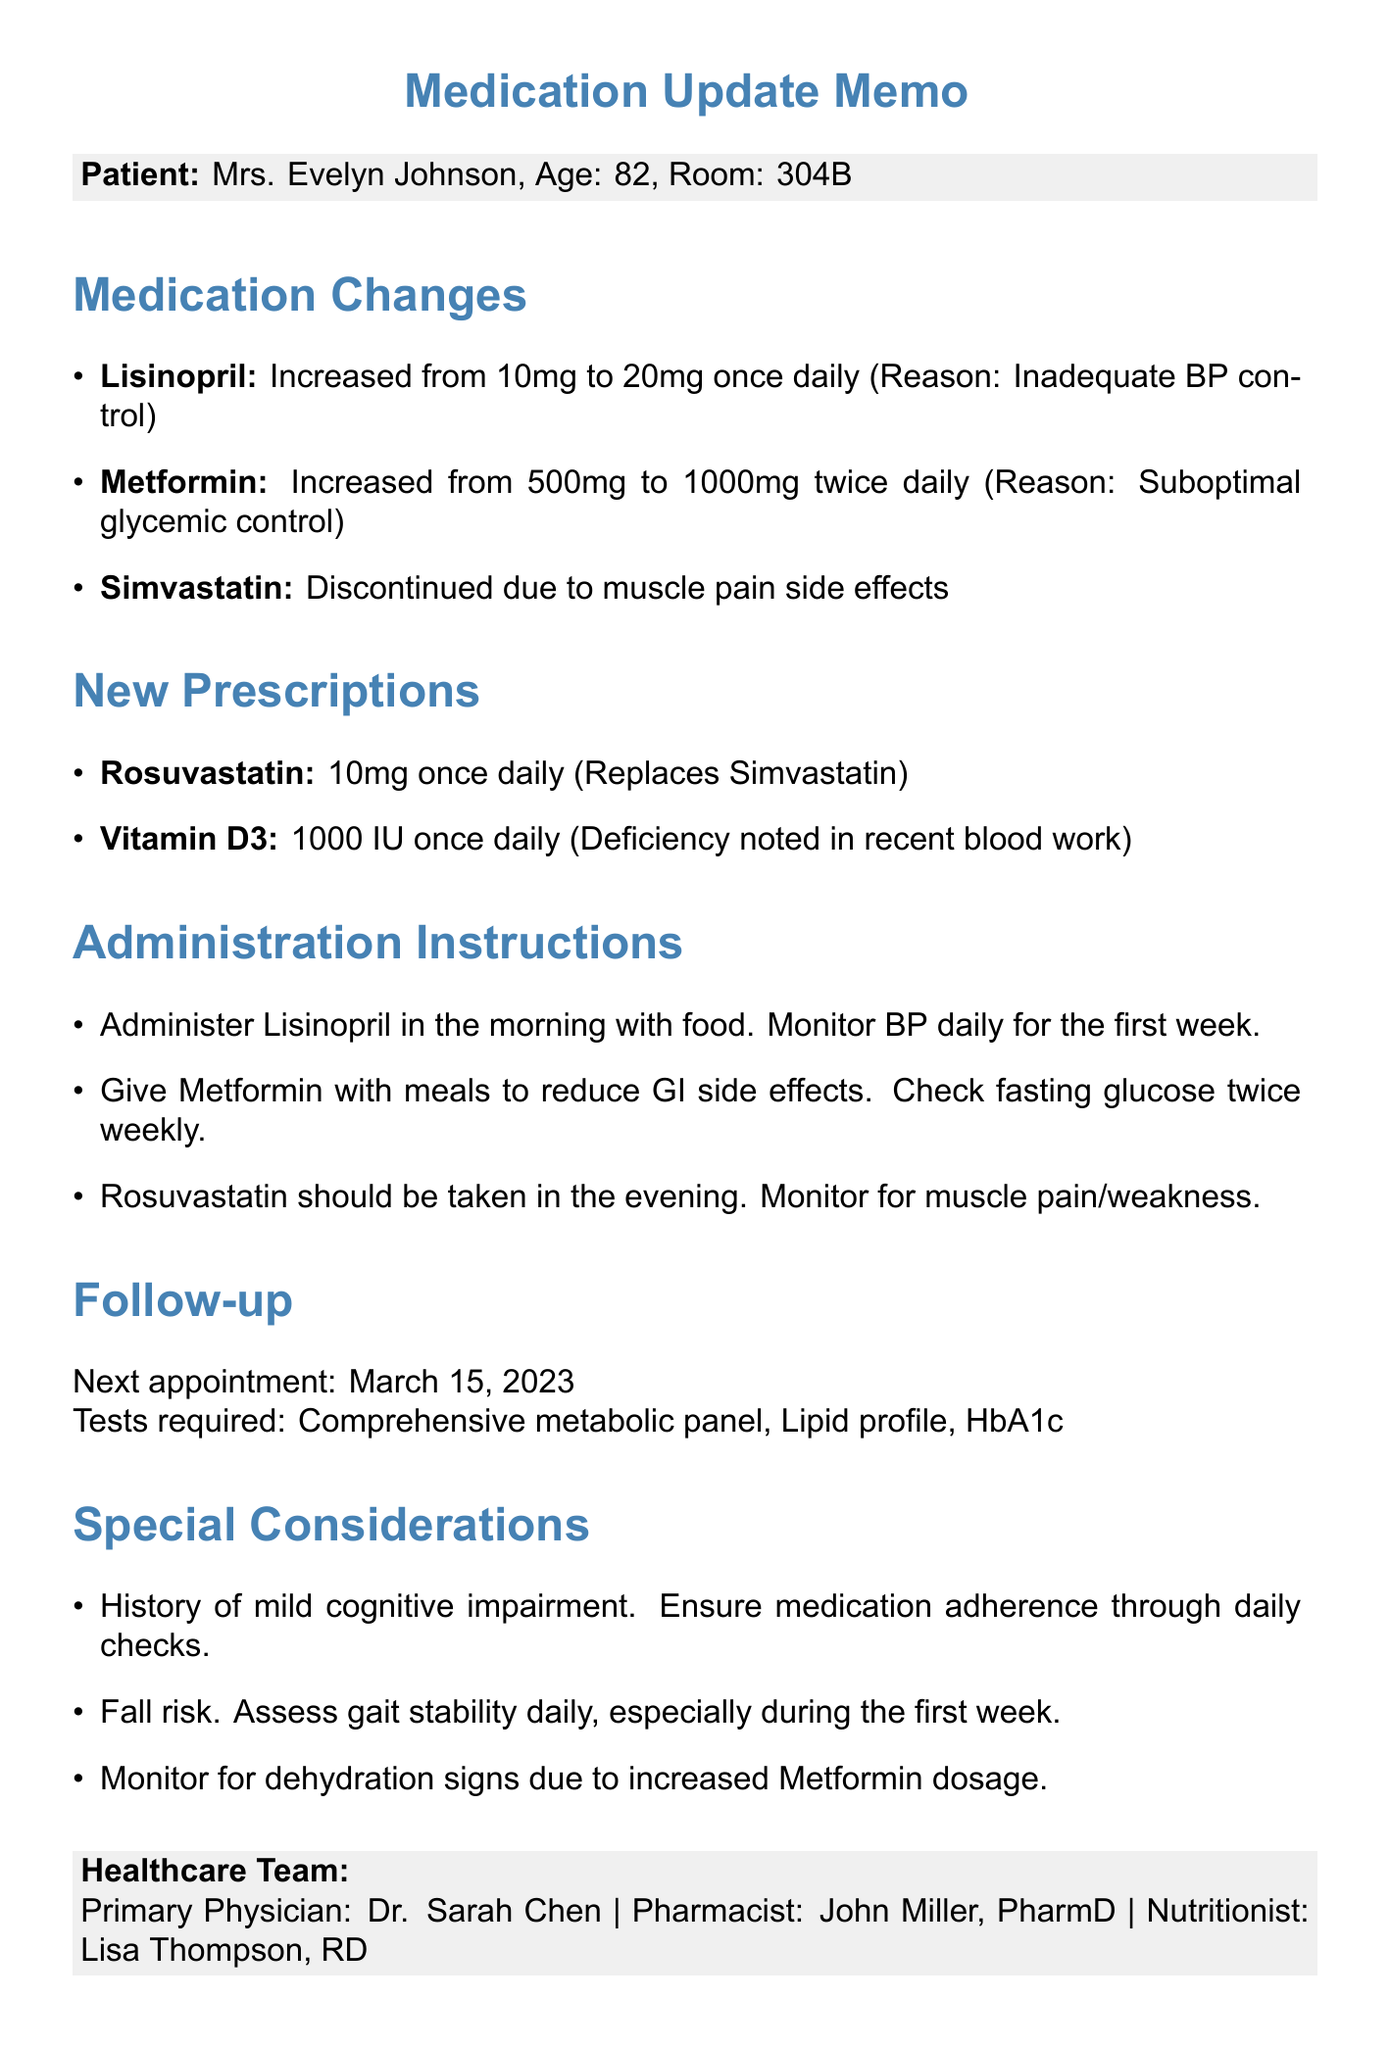What is the name of the patient? The name of the patient is stated clearly at the beginning of the document.
Answer: Mrs. Evelyn Johnson What is the age of Mrs. Johnson? The age of the patient is specified in the document as part of her identification.
Answer: 82 What was the previous dosage of Metformin? The document lists specific dosage changes for each medication, including previous dosages.
Answer: 500mg twice daily What is the reason for increasing Lisinopril dosage? The document provides reasons for changes in medication dosages, explaining the rationale behind them.
Answer: Inadequate blood pressure control What drug is Rosuvastatin replacing? The new prescriptions section indicates the purpose of Rosuvastatin clearly.
Answer: Simvastatin When is the next appointment scheduled? The follow-up section specifies the date of the next appointment for the patient.
Answer: March 15, 2023 What must be monitored daily for the first week after starting Lisinopril? The administration instructions highlight important monitoring tasks associated with new medications.
Answer: Blood pressure What side effect led to the discontinuation of Simvastatin? The reasoning for discontinuing medications is briefly noted in the medication changes section.
Answer: Muscle pain side effects Who is the primary physician for Mrs. Johnson? The healthcare team section lists the primary physician responsible for the patient's care.
Answer: Dr. Sarah Chen 